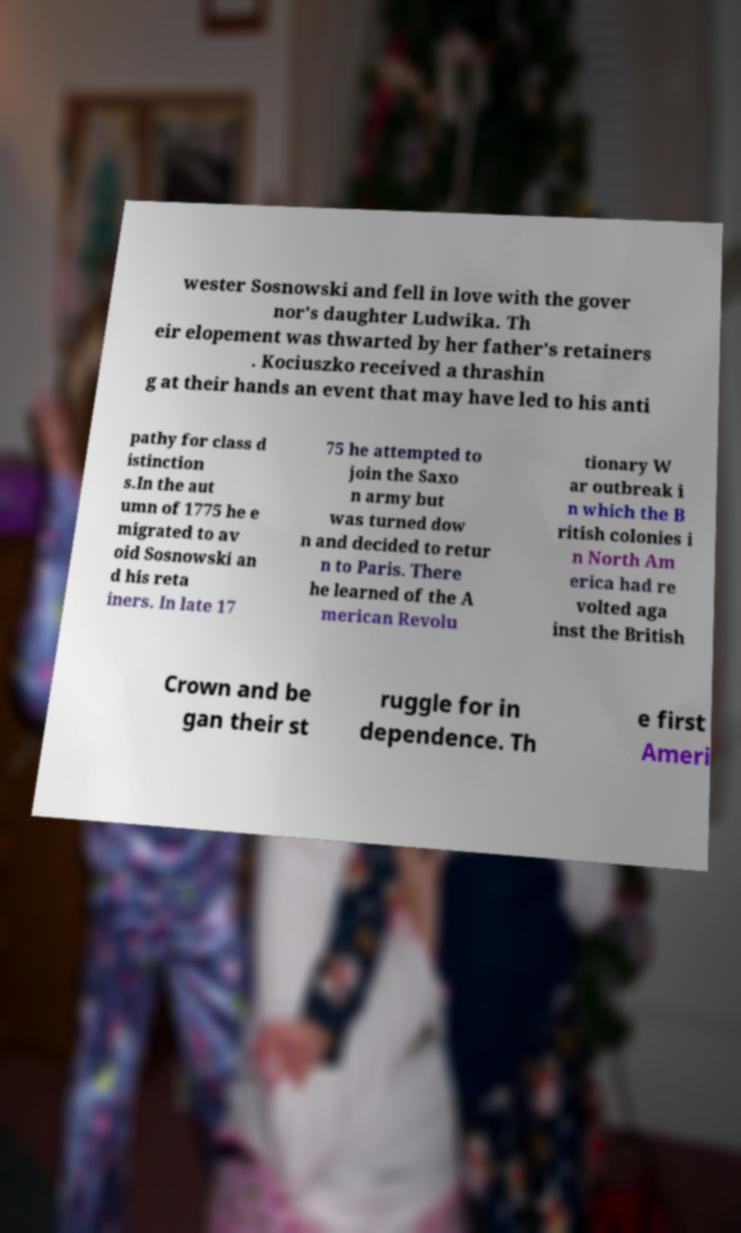I need the written content from this picture converted into text. Can you do that? wester Sosnowski and fell in love with the gover nor's daughter Ludwika. Th eir elopement was thwarted by her father's retainers . Kociuszko received a thrashin g at their hands an event that may have led to his anti pathy for class d istinction s.In the aut umn of 1775 he e migrated to av oid Sosnowski an d his reta iners. In late 17 75 he attempted to join the Saxo n army but was turned dow n and decided to retur n to Paris. There he learned of the A merican Revolu tionary W ar outbreak i n which the B ritish colonies i n North Am erica had re volted aga inst the British Crown and be gan their st ruggle for in dependence. Th e first Ameri 